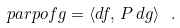<formula> <loc_0><loc_0><loc_500><loc_500>\ p a r p o { f } { g } = \langle d f , \, P \, d g \rangle \ .</formula> 